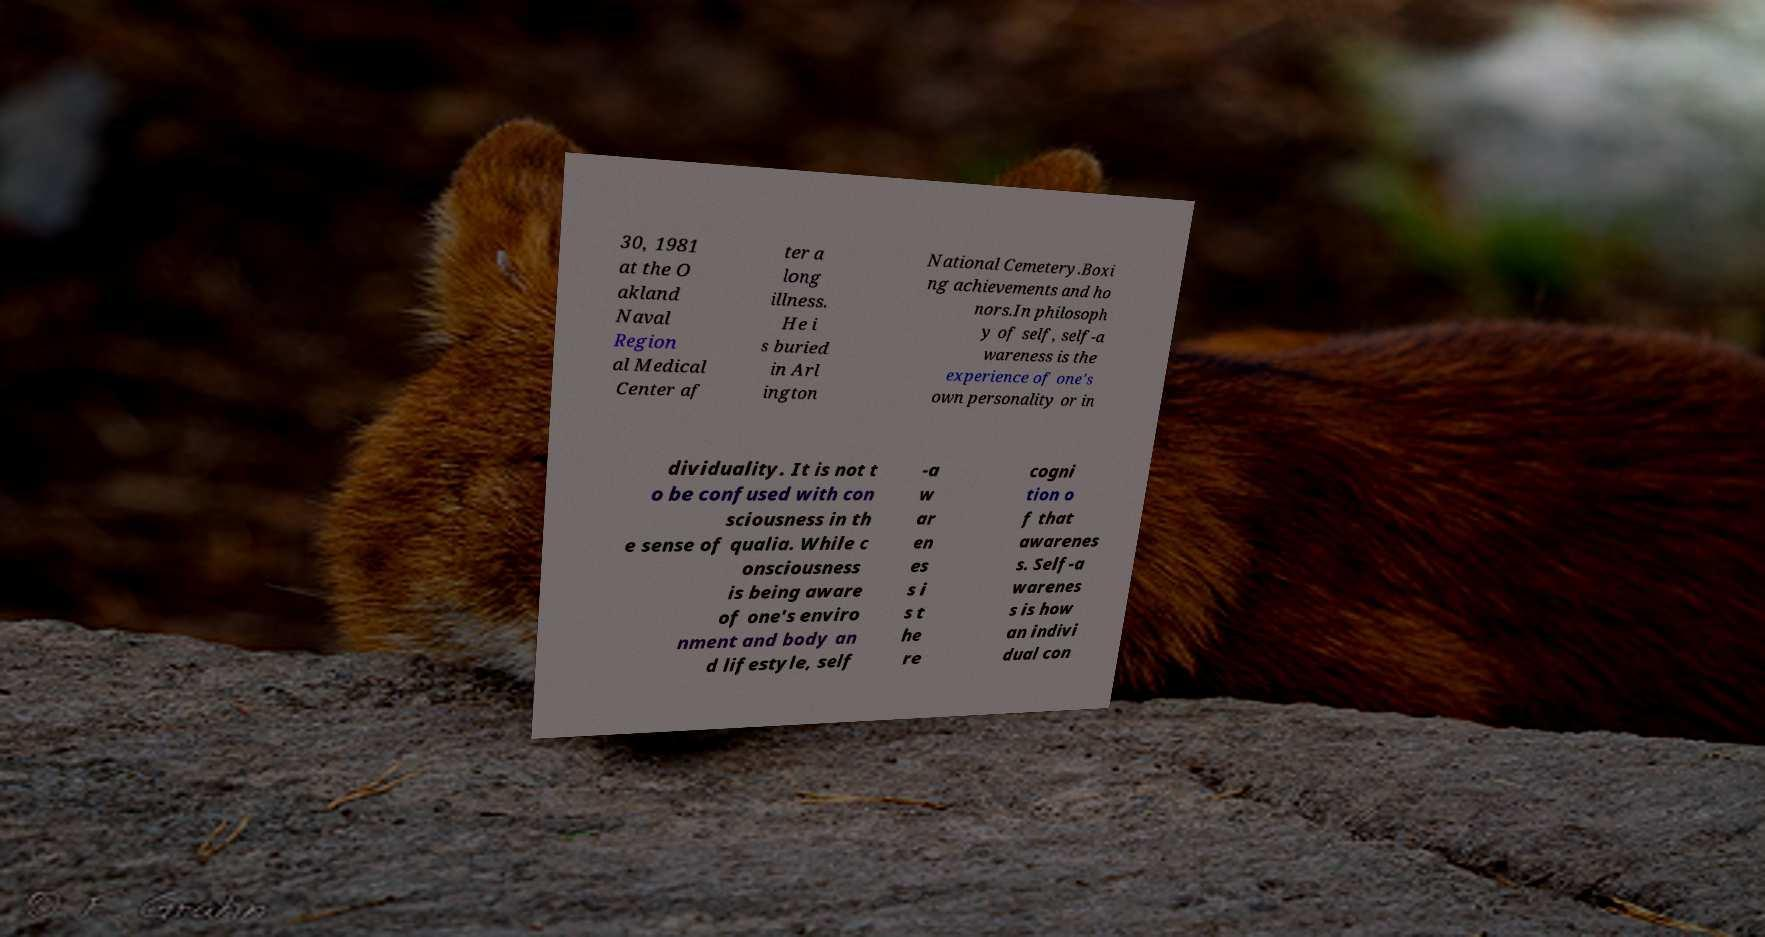Can you accurately transcribe the text from the provided image for me? 30, 1981 at the O akland Naval Region al Medical Center af ter a long illness. He i s buried in Arl ington National Cemetery.Boxi ng achievements and ho nors.In philosoph y of self, self-a wareness is the experience of one's own personality or in dividuality. It is not t o be confused with con sciousness in th e sense of qualia. While c onsciousness is being aware of one's enviro nment and body an d lifestyle, self -a w ar en es s i s t he re cogni tion o f that awarenes s. Self-a warenes s is how an indivi dual con 